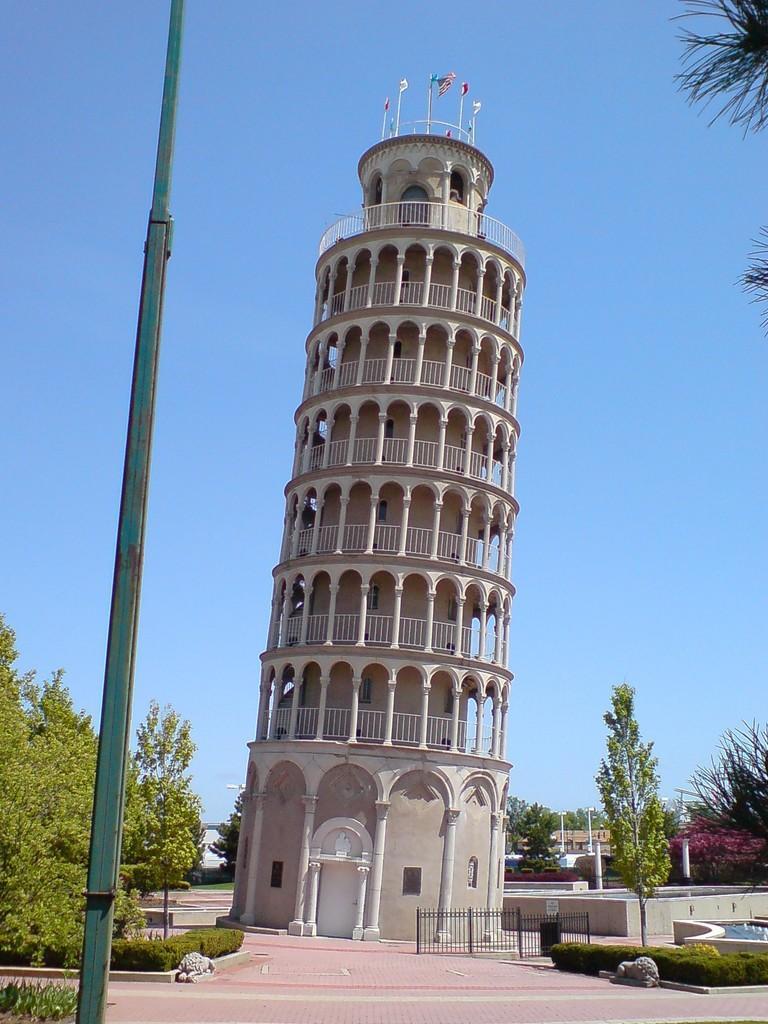How would you summarize this image in a sentence or two? As we can see in the image there are buildings, trees, fence, plants and water. At the top there is sky and there are flags. 